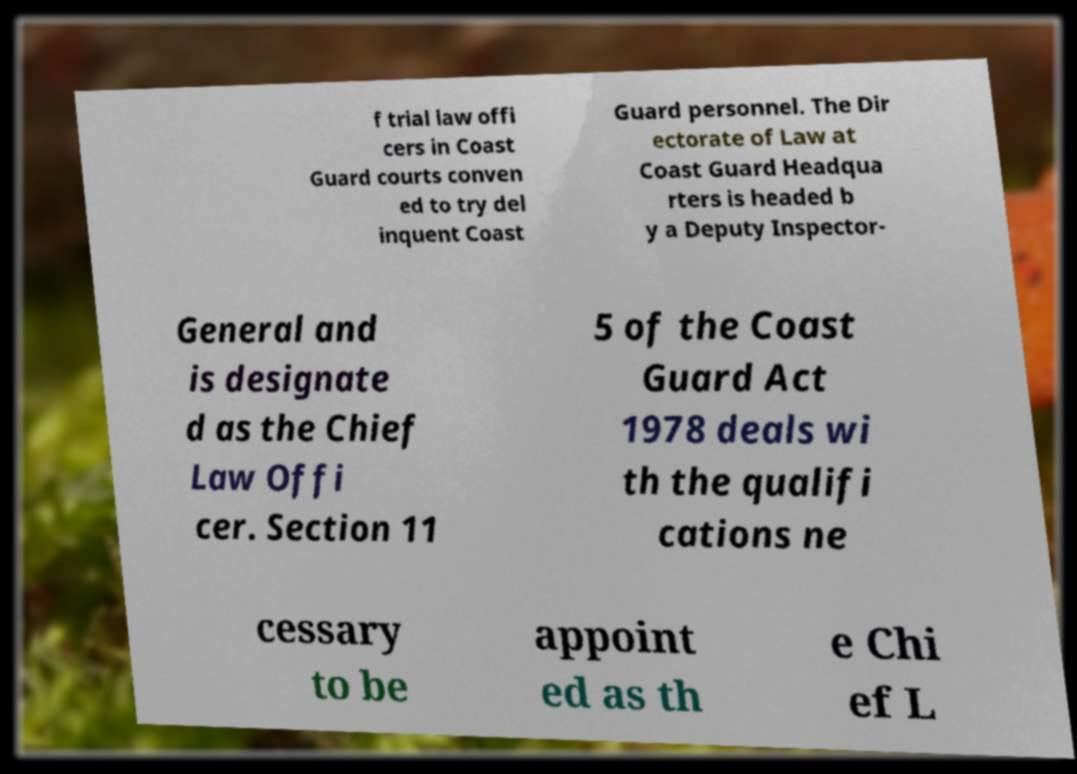I need the written content from this picture converted into text. Can you do that? f trial law offi cers in Coast Guard courts conven ed to try del inquent Coast Guard personnel. The Dir ectorate of Law at Coast Guard Headqua rters is headed b y a Deputy Inspector- General and is designate d as the Chief Law Offi cer. Section 11 5 of the Coast Guard Act 1978 deals wi th the qualifi cations ne cessary to be appoint ed as th e Chi ef L 